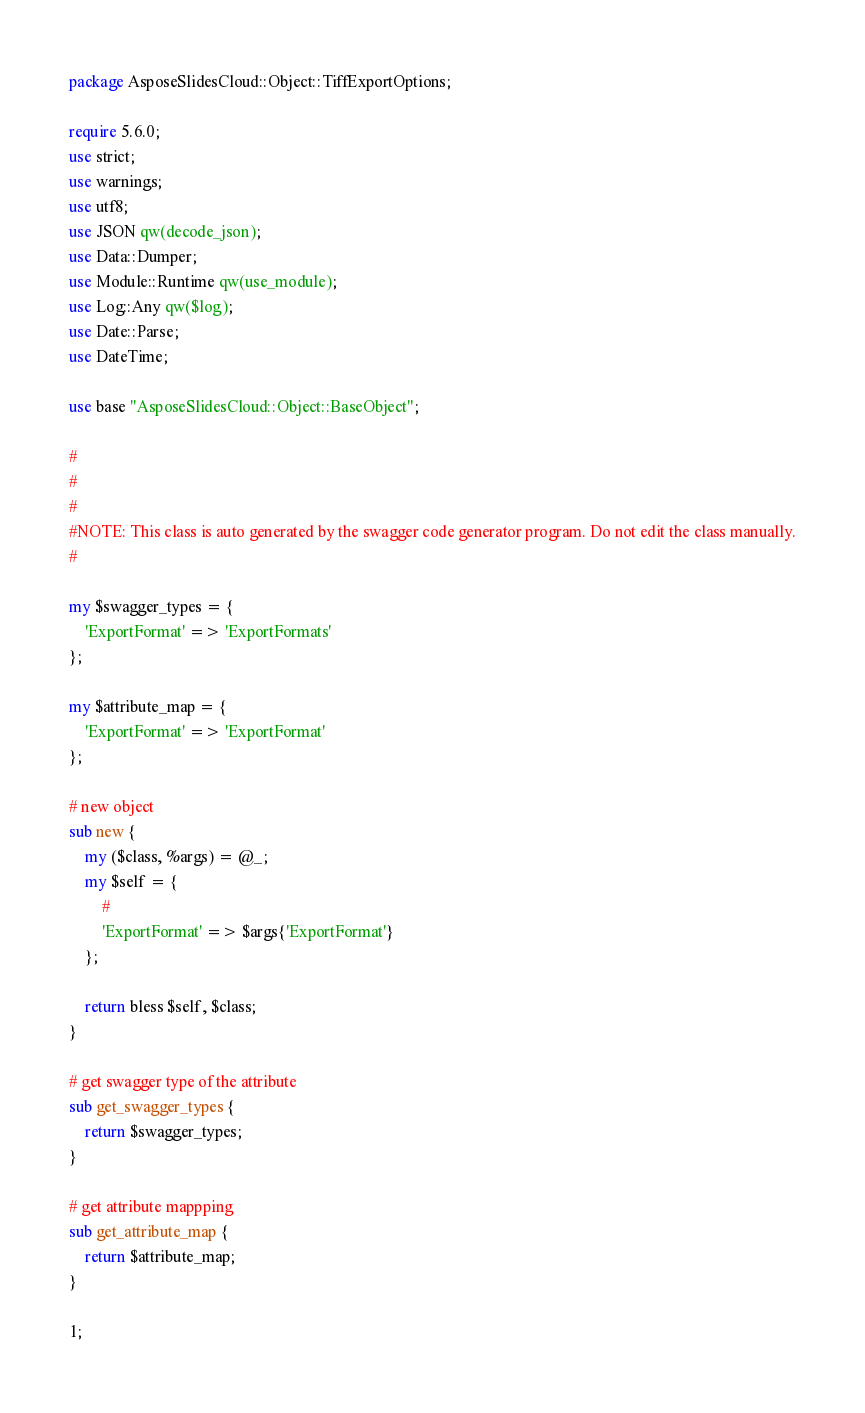Convert code to text. <code><loc_0><loc_0><loc_500><loc_500><_Perl_>package AsposeSlidesCloud::Object::TiffExportOptions;

require 5.6.0;
use strict;
use warnings;
use utf8;
use JSON qw(decode_json);
use Data::Dumper;
use Module::Runtime qw(use_module);
use Log::Any qw($log);
use Date::Parse;
use DateTime;

use base "AsposeSlidesCloud::Object::BaseObject";

#
#
#
#NOTE: This class is auto generated by the swagger code generator program. Do not edit the class manually.
#

my $swagger_types = {
    'ExportFormat' => 'ExportFormats'
};

my $attribute_map = {
    'ExportFormat' => 'ExportFormat'
};

# new object
sub new { 
    my ($class, %args) = @_; 
    my $self = { 
        #
        'ExportFormat' => $args{'ExportFormat'}
    }; 

    return bless $self, $class; 
}  

# get swagger type of the attribute
sub get_swagger_types {
    return $swagger_types;
}

# get attribute mappping
sub get_attribute_map {
    return $attribute_map;
}

1;
</code> 